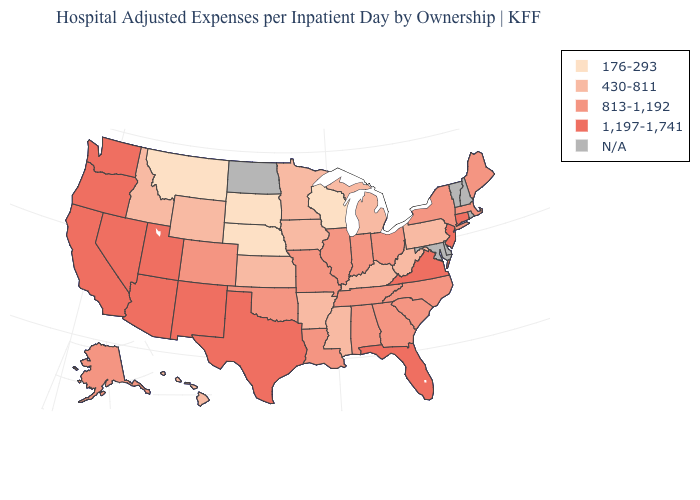What is the value of Colorado?
Give a very brief answer. 813-1,192. Does the map have missing data?
Short answer required. Yes. Name the states that have a value in the range 813-1,192?
Answer briefly. Alabama, Alaska, Colorado, Georgia, Illinois, Indiana, Louisiana, Maine, Massachusetts, Missouri, New York, North Carolina, Ohio, Oklahoma, South Carolina, Tennessee. What is the value of New Jersey?
Write a very short answer. 1,197-1,741. Does New York have the lowest value in the Northeast?
Short answer required. No. Does the map have missing data?
Answer briefly. Yes. Which states have the highest value in the USA?
Be succinct. Arizona, California, Connecticut, Florida, Nevada, New Jersey, New Mexico, Oregon, Texas, Utah, Virginia, Washington. Is the legend a continuous bar?
Write a very short answer. No. Name the states that have a value in the range 813-1,192?
Keep it brief. Alabama, Alaska, Colorado, Georgia, Illinois, Indiana, Louisiana, Maine, Massachusetts, Missouri, New York, North Carolina, Ohio, Oklahoma, South Carolina, Tennessee. Does Texas have the highest value in the USA?
Be succinct. Yes. Among the states that border Oklahoma , which have the lowest value?
Concise answer only. Arkansas, Kansas. Which states hav the highest value in the Northeast?
Concise answer only. Connecticut, New Jersey. Among the states that border Georgia , which have the highest value?
Quick response, please. Florida. What is the lowest value in the USA?
Write a very short answer. 176-293. 